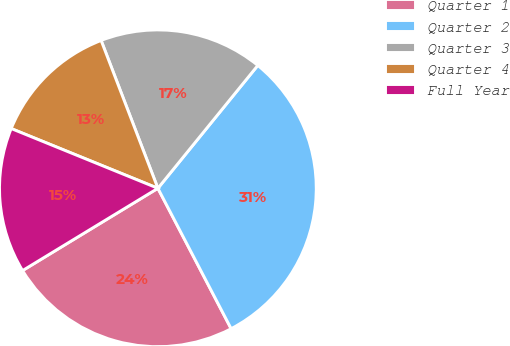Convert chart. <chart><loc_0><loc_0><loc_500><loc_500><pie_chart><fcel>Quarter 1<fcel>Quarter 2<fcel>Quarter 3<fcel>Quarter 4<fcel>Full Year<nl><fcel>23.96%<fcel>31.48%<fcel>16.7%<fcel>13.01%<fcel>14.85%<nl></chart> 